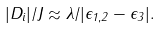Convert formula to latex. <formula><loc_0><loc_0><loc_500><loc_500>| D _ { i } | / J \approx \lambda / | \epsilon _ { 1 , 2 } - \epsilon _ { 3 } | .</formula> 